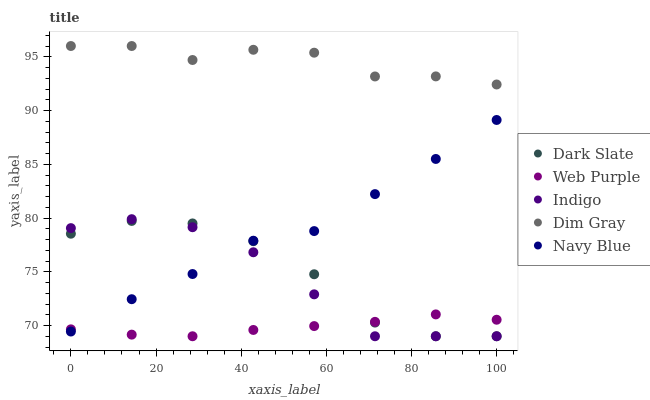Does Web Purple have the minimum area under the curve?
Answer yes or no. Yes. Does Dim Gray have the maximum area under the curve?
Answer yes or no. Yes. Does Dim Gray have the minimum area under the curve?
Answer yes or no. No. Does Web Purple have the maximum area under the curve?
Answer yes or no. No. Is Web Purple the smoothest?
Answer yes or no. Yes. Is Dark Slate the roughest?
Answer yes or no. Yes. Is Dim Gray the smoothest?
Answer yes or no. No. Is Dim Gray the roughest?
Answer yes or no. No. Does Dark Slate have the lowest value?
Answer yes or no. Yes. Does Dim Gray have the lowest value?
Answer yes or no. No. Does Dim Gray have the highest value?
Answer yes or no. Yes. Does Web Purple have the highest value?
Answer yes or no. No. Is Web Purple less than Dim Gray?
Answer yes or no. Yes. Is Dim Gray greater than Web Purple?
Answer yes or no. Yes. Does Navy Blue intersect Web Purple?
Answer yes or no. Yes. Is Navy Blue less than Web Purple?
Answer yes or no. No. Is Navy Blue greater than Web Purple?
Answer yes or no. No. Does Web Purple intersect Dim Gray?
Answer yes or no. No. 